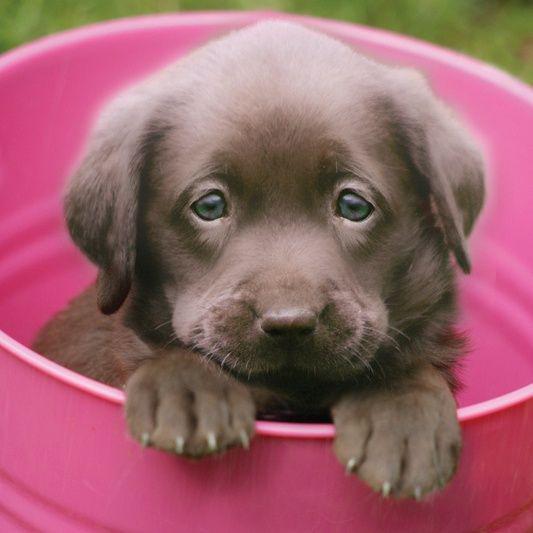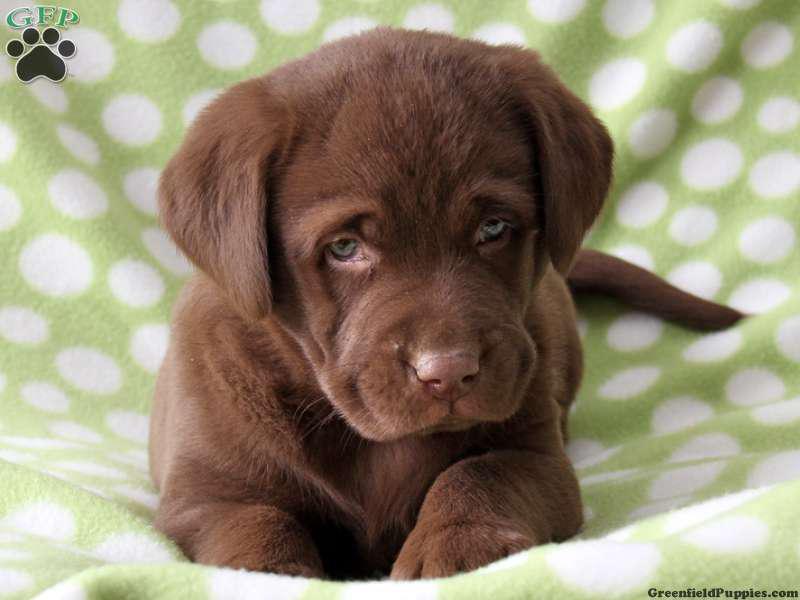The first image is the image on the left, the second image is the image on the right. Analyze the images presented: Is the assertion "A brown puppy is posed on a printed fabric surface." valid? Answer yes or no. Yes. The first image is the image on the left, the second image is the image on the right. Given the left and right images, does the statement "the animal in the image on the left is in a container" hold true? Answer yes or no. Yes. 